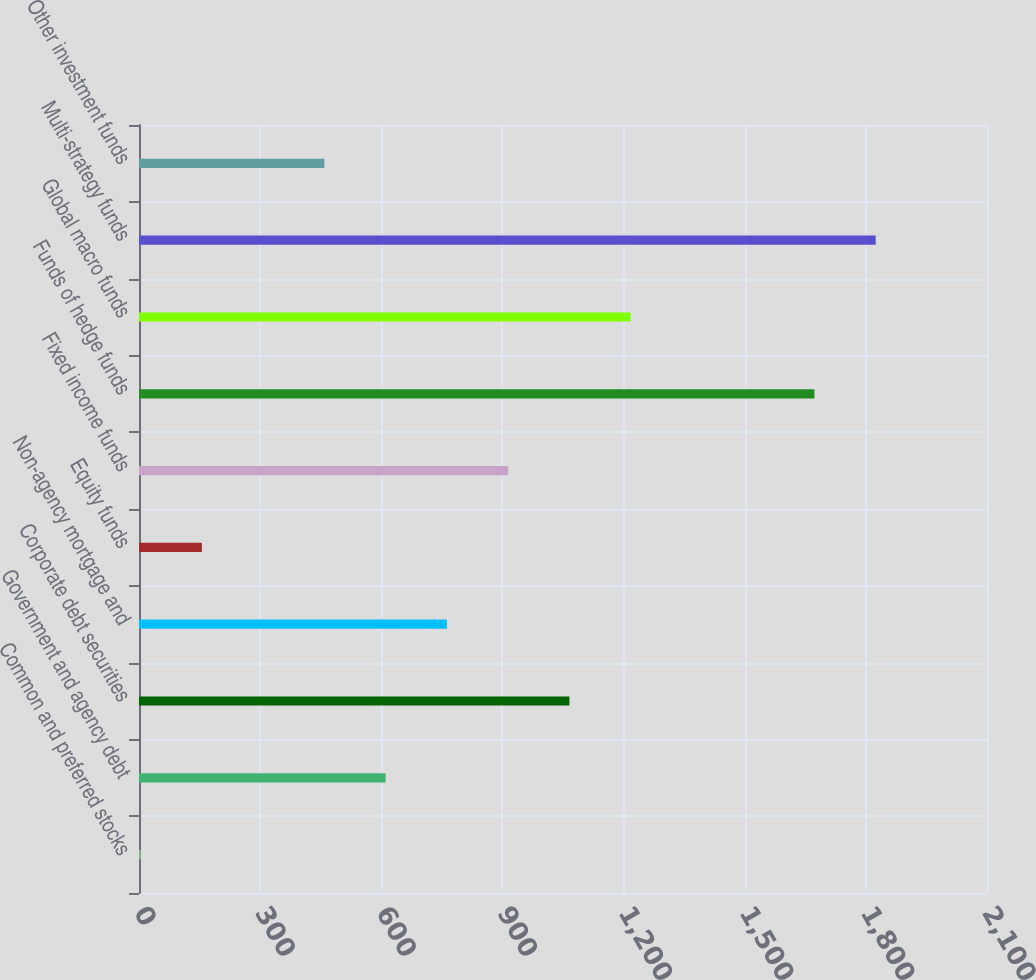<chart> <loc_0><loc_0><loc_500><loc_500><bar_chart><fcel>Common and preferred stocks<fcel>Government and agency debt<fcel>Corporate debt securities<fcel>Non-agency mortgage and<fcel>Equity funds<fcel>Fixed income funds<fcel>Funds of hedge funds<fcel>Global macro funds<fcel>Multi-strategy funds<fcel>Other investment funds<nl><fcel>4<fcel>610.8<fcel>1065.9<fcel>762.5<fcel>155.7<fcel>914.2<fcel>1672.7<fcel>1217.6<fcel>1824.4<fcel>459.1<nl></chart> 